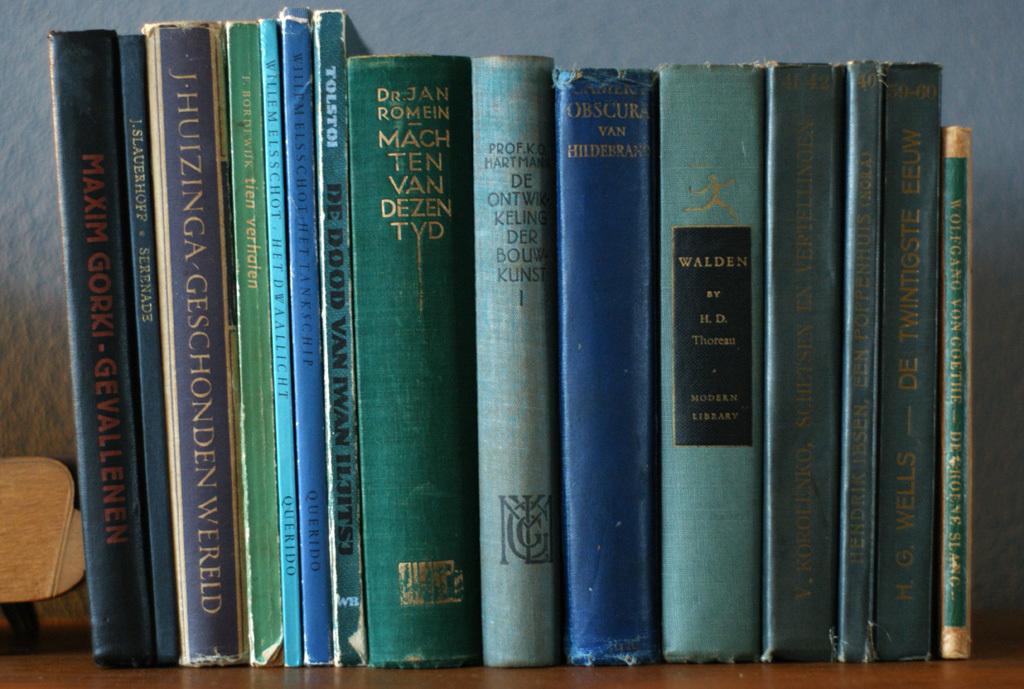Who is the author of the book on the far left?
Ensure brevity in your answer.  Maxim gorki. Are most of the books blue in color?
Offer a very short reply. Answering does not require reading text in the image. 